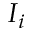Convert formula to latex. <formula><loc_0><loc_0><loc_500><loc_500>I _ { i }</formula> 